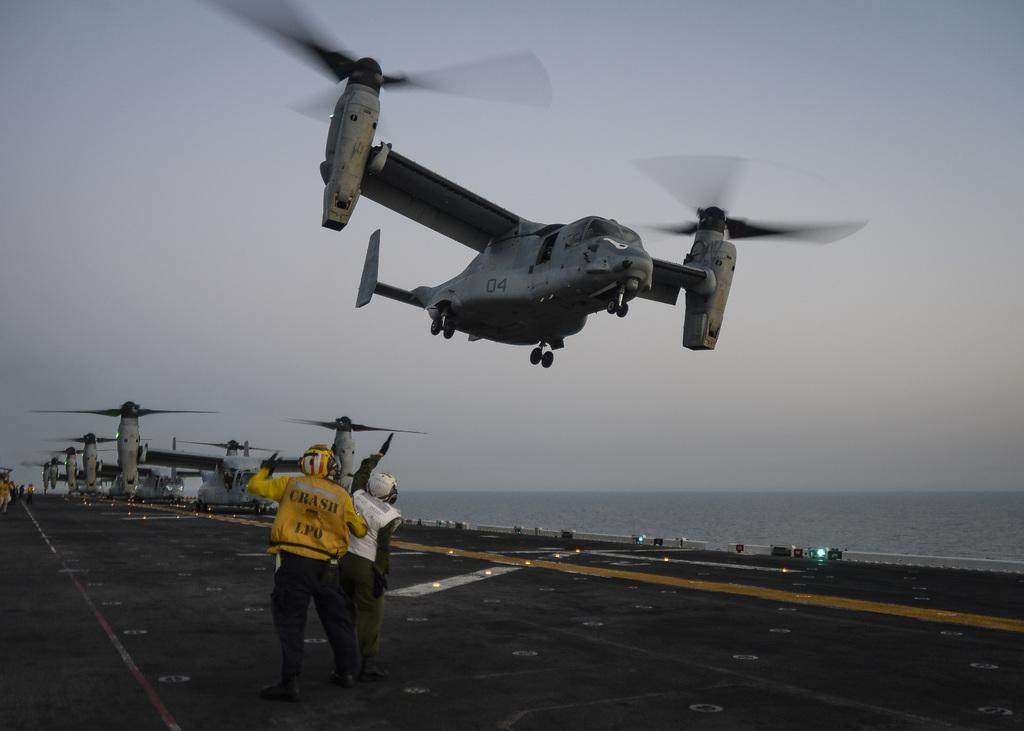<image>
Give a short and clear explanation of the subsequent image. Two men, one wearing a yellow jacket that says "CRSAH LPO" signaling to a helicopter on an aircraft carrier. 